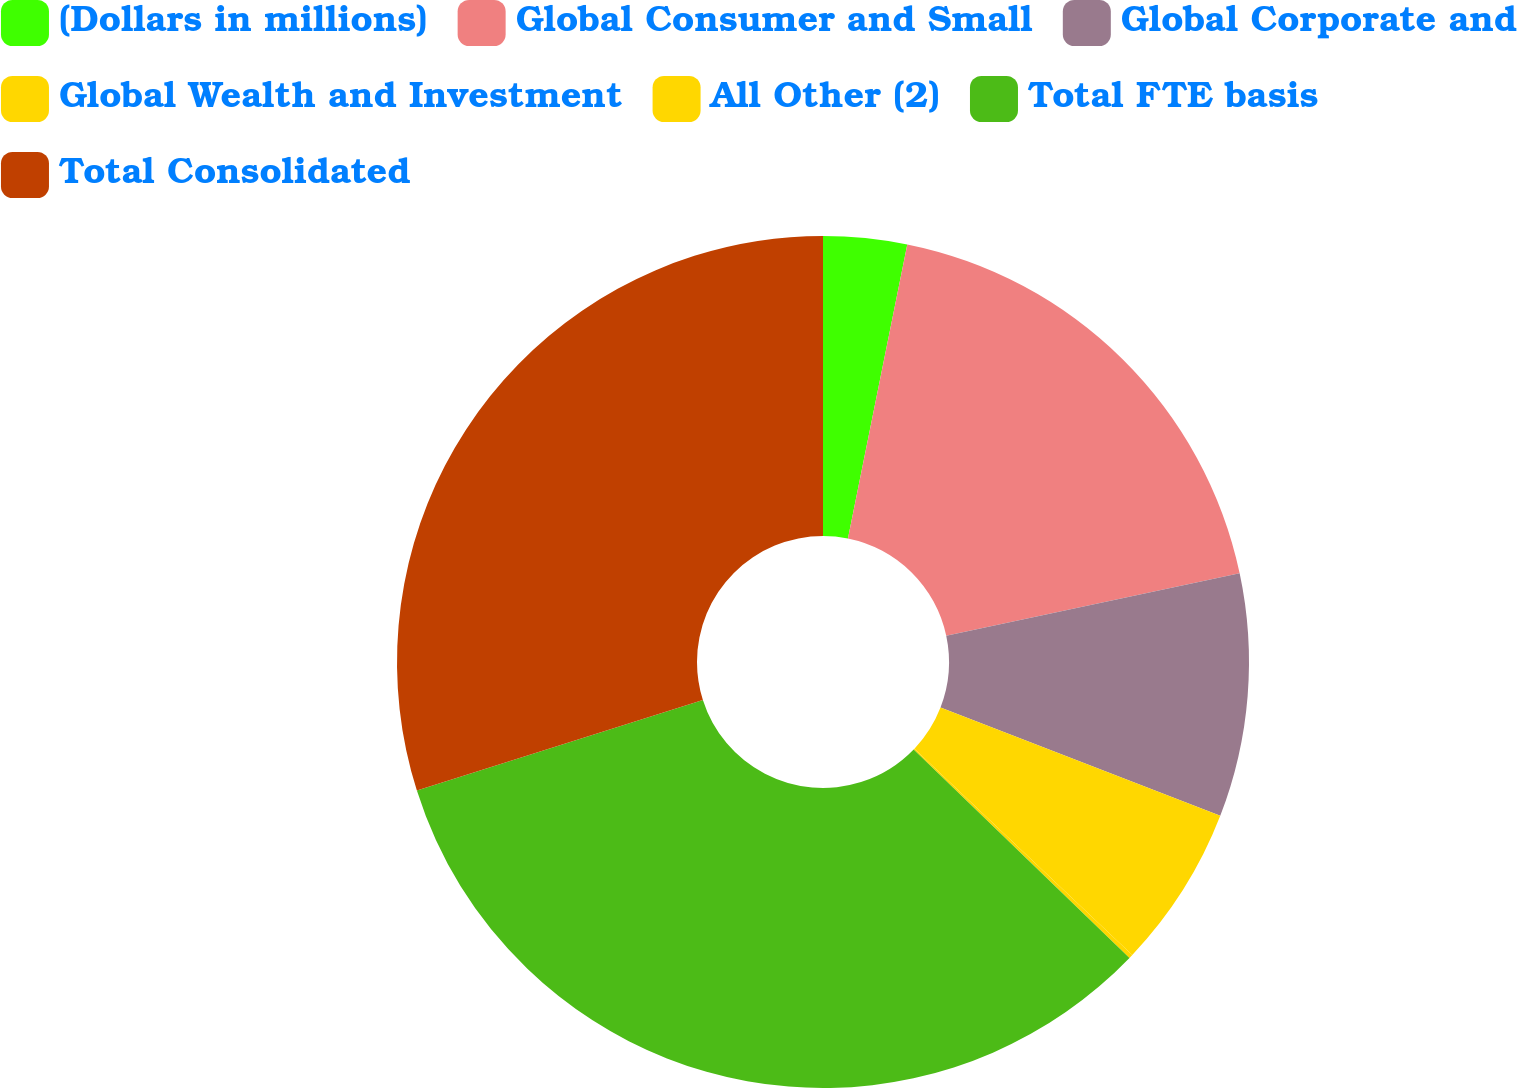Convert chart to OTSL. <chart><loc_0><loc_0><loc_500><loc_500><pie_chart><fcel>(Dollars in millions)<fcel>Global Consumer and Small<fcel>Global Corporate and<fcel>Global Wealth and Investment<fcel>All Other (2)<fcel>Total FTE basis<fcel>Total Consolidated<nl><fcel>3.17%<fcel>18.49%<fcel>9.22%<fcel>6.19%<fcel>0.15%<fcel>32.9%<fcel>29.88%<nl></chart> 